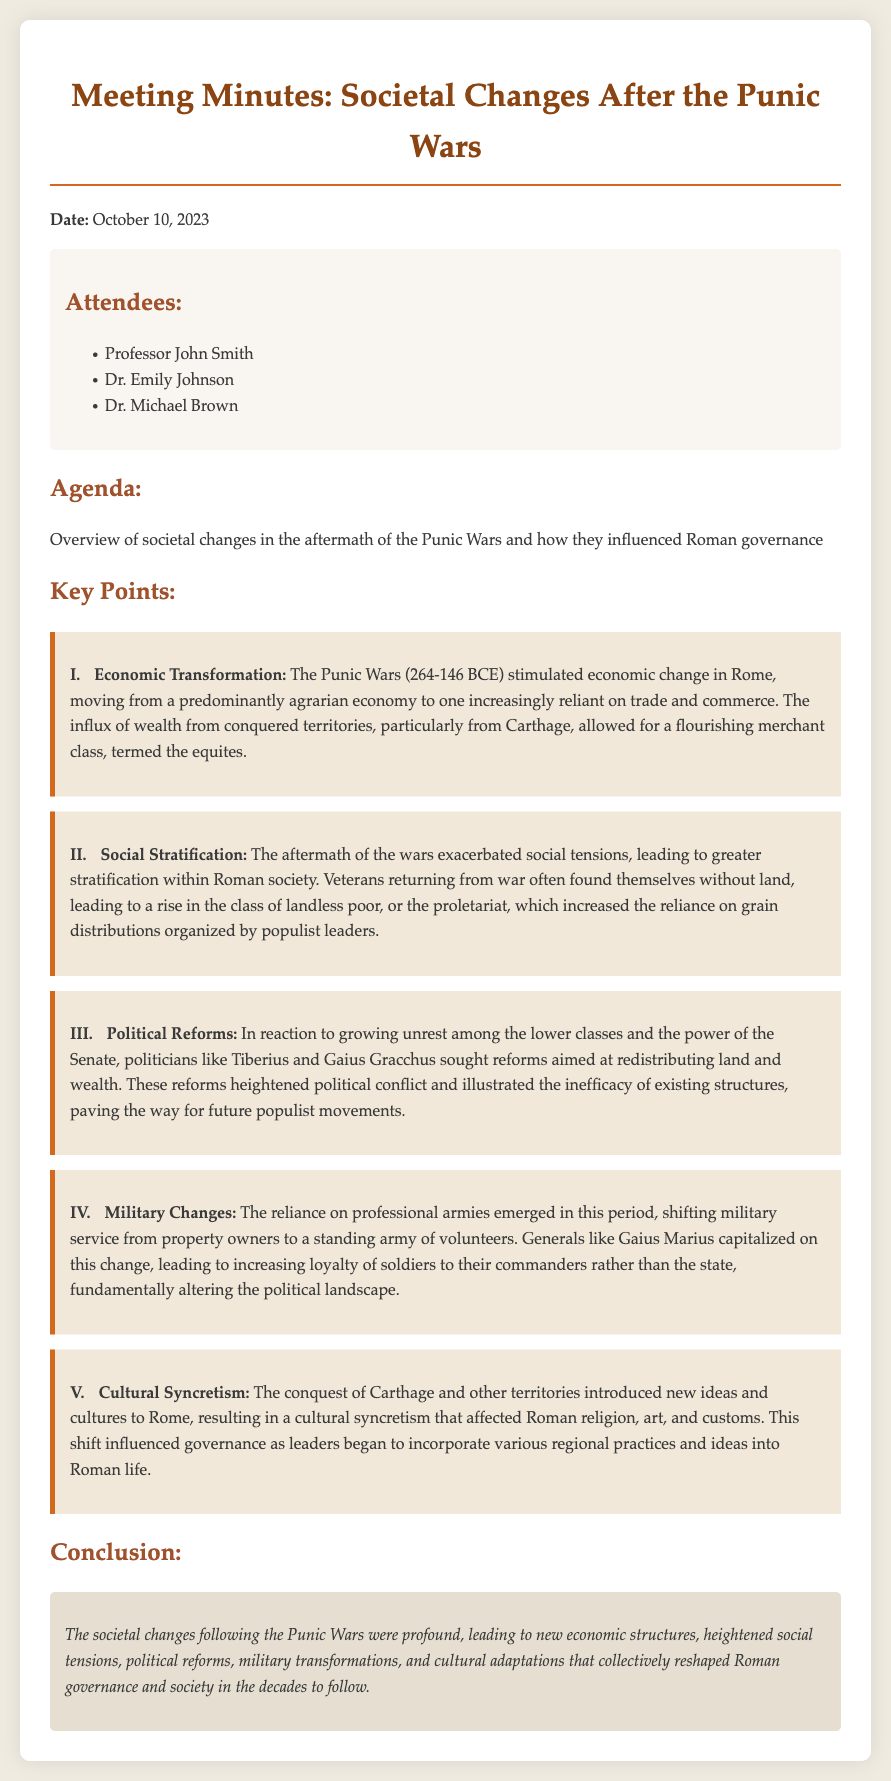What was the date of the meeting? The date of the meeting is explicitly stated in the document.
Answer: October 10, 2023 Who were the attendees? The attendees' names are listed under the "Attendees" section of the document.
Answer: Professor John Smith, Dr. Emily Johnson, Dr. Michael Brown What economic transformation occurred after the Punic Wars? This is mentioned in the key points section focusing on economic change.
Answer: Movement from a predominantly agrarian economy to one increasingly reliant on trade and commerce Who sought political reforms aimed at redistributing land and wealth? This information can be found in the key points regarding political reforms.
Answer: Tiberius and Gaius Gracchus What class emerged due to veterans returning from war without land? This detail is discussed in the key point on social stratification.
Answer: Proletariat Which general capitalized on the shift to a professional army? This fact is noted in the section about military changes.
Answer: Gaius Marius What was the main cultural influence after the conquest of Carthage? The cultural changes are outlined in the key point about cultural syncretism.
Answer: Incorporation of various regional practices and ideas into Roman life What was the conclusion about the societal changes? The conclusion summarizes the overall impact of the societal changes outlined in the document.
Answer: Profound, leading to new economic structures, heightened social tensions, political reforms, military transformations, and cultural adaptations 